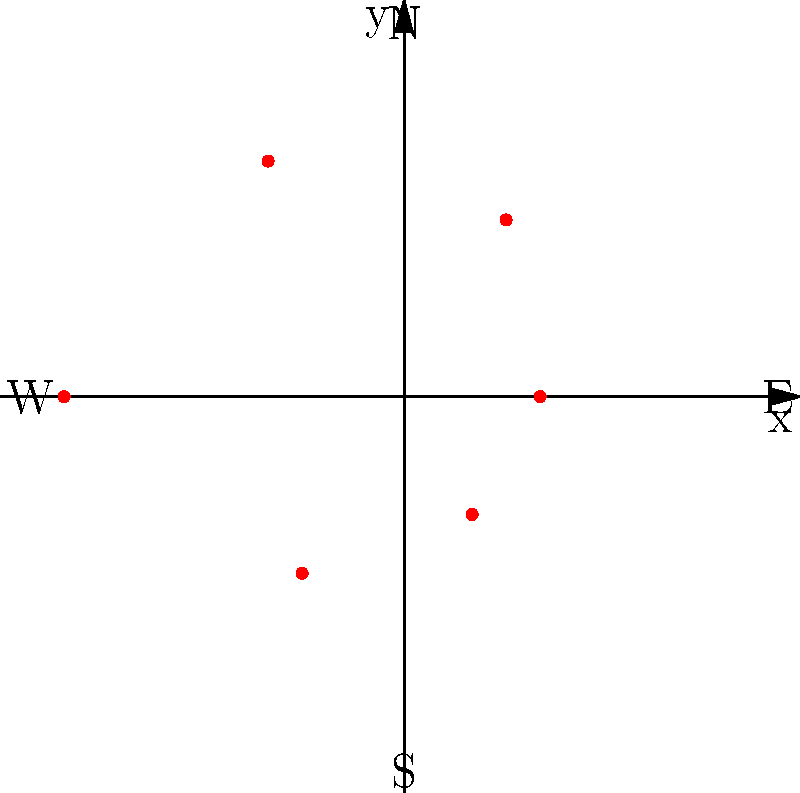The polar graph above represents the distribution of ring forts in different directions around a central point in Laois county. Each dot represents the number of ring forts (distance from center) in a particular direction. In which cardinal direction are ring forts most abundant? To determine the direction with the most ring forts, we need to analyze the polar graph:

1. The graph shows six points representing ring fort distributions in different directions.
2. Each point's distance from the center indicates the number of ring forts in that direction.
3. The cardinal directions are labeled on the graph (N, E, S, W).
4. We need to identify the point furthest from the center, which represents the highest number of ring forts.

Examining the graph:
- North (top): moderately distant from center
- Northeast: close to center
- Southeast: furthest from center
- South: second furthest from center
- Southwest: close to center
- Northwest: moderately distant from center

The point in the Southeast direction is the furthest from the center, indicating the highest number of ring forts.
Answer: Southeast 